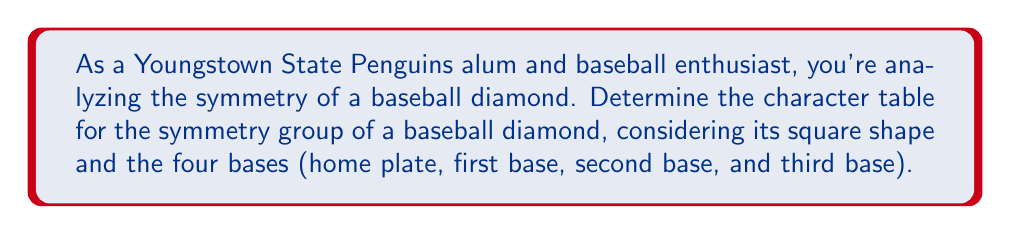Help me with this question. Let's approach this step-by-step:

1) First, identify the symmetry group of a baseball diamond. It's the same as the symmetry group of a square, which is the dihedral group $D_4$.

2) $D_4$ has 8 elements:
   - Identity (e)
   - 90° rotations ($r$, $r^2$, $r^3$)
   - Reflections across diagonals ($d_1$, $d_2$)
   - Reflections across perpendicular bisectors ($h$, $v$)

3) $D_4$ has 5 conjugacy classes:
   - {e}
   - {$r^2$}
   - {$r$, $r^3$}
   - {$d_1$, $d_2$}
   - {$h$, $v$}

4) Therefore, $D_4$ has 5 irreducible representations.

5) We know that:
   - There's always a trivial representation (all 1's)
   - For even-order dihedral groups, there's always a representation where rotations are 1 and reflections are -1
   - For $D_4$, there are two more 1-dimensional representations
   - The remaining representation must be 2-dimensional to satisfy $1^2 + 1^2 + 1^2 + 1^2 + 2^2 = 8$

6) Let's call these representations $\chi_1$ (trivial), $\chi_2$, $\chi_3$, $\chi_4$, and $\chi_5$ (2-dimensional).

7) For $\chi_2$: rotations = 1, reflections = -1
   For $\chi_3$: $r$, $r^3$, $d_1$, $d_2$ = -1; others = 1
   For $\chi_4$: $r$, $r^3$, $h$, $v$ = -1; others = 1

8) For $\chi_5$, we can deduce:
   $\chi_5(e) = 2$ (trace of 2x2 identity matrix)
   $\chi_5(r^2) = -2$ (180° rotation in 2D is -I)
   $\chi_5(r) = \chi_5(r^3) = 0$ (90° rotation in 2D has trace 0)
   $\chi_5(d_1) = \chi_5(d_2) = 0$ (reflection in 2D has determinant -1 and trace 0)
   $\chi_5(h) = \chi_5(v) = 0$ (same reason as diagonals)

9) Putting it all together in a table:

$$
\begin{array}{c|ccccc}
D_4 & e & r^2 & r,r^3 & d_1,d_2 & h,v \\
\hline
\chi_1 & 1 & 1 & 1 & 1 & 1 \\
\chi_2 & 1 & 1 & 1 & -1 & -1 \\
\chi_3 & 1 & 1 & -1 & 1 & -1 \\
\chi_4 & 1 & 1 & -1 & -1 & 1 \\
\chi_5 & 2 & -2 & 0 & 0 & 0
\end{array}
$$

This is the character table for the symmetry group of a baseball diamond.
Answer: $$
\begin{array}{c|ccccc}
D_4 & e & r^2 & r,r^3 & d_1,d_2 & h,v \\
\hline
\chi_1 & 1 & 1 & 1 & 1 & 1 \\
\chi_2 & 1 & 1 & 1 & -1 & -1 \\
\chi_3 & 1 & 1 & -1 & 1 & -1 \\
\chi_4 & 1 & 1 & -1 & -1 & 1 \\
\chi_5 & 2 & -2 & 0 & 0 & 0
\end{array}
$$ 